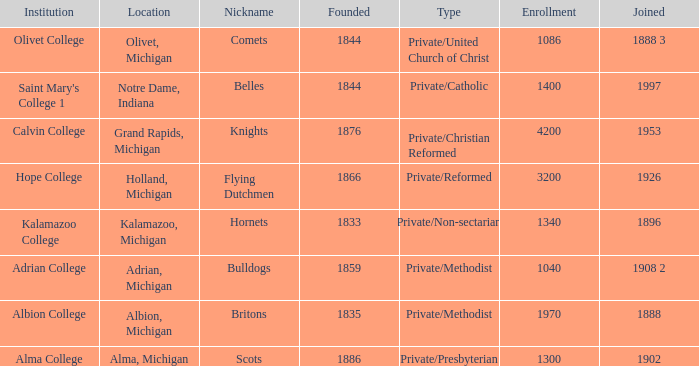How many categories fall under the category of britons? 1.0. 